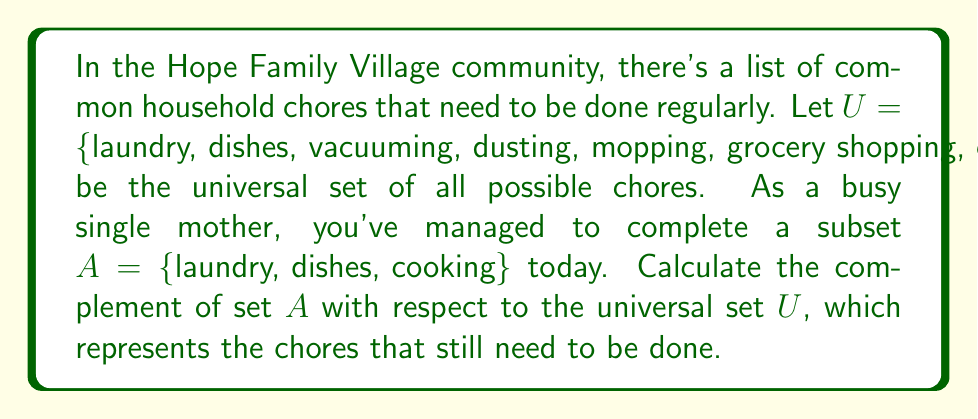What is the answer to this math problem? To solve this problem, we need to find the complement of set $A$ with respect to the universal set $U$. The complement of a set $A$, denoted as $A^c$ or $\overline{A}$, is the set of all elements in the universal set $U$ that are not in $A$.

Given:
$U = \{$laundry, dishes, vacuuming, dusting, mopping, grocery shopping, cooking, taking out trash$\}$
$A = \{$laundry, dishes, cooking$\}$

To find $A^c$:
1. Identify all elements in $U$ that are not in $A$.
2. List these elements to form the complement set.

Elements in $U$ but not in $A$:
- vacuuming
- dusting
- mopping
- grocery shopping
- taking out trash

Therefore, the complement of $A$ is:
$A^c = \{$vacuuming, dusting, mopping, grocery shopping, taking out trash$\}$

This set represents the chores that still need to be done in the household.
Answer: $A^c = \{$vacuuming, dusting, mopping, grocery shopping, taking out trash$\}$ 